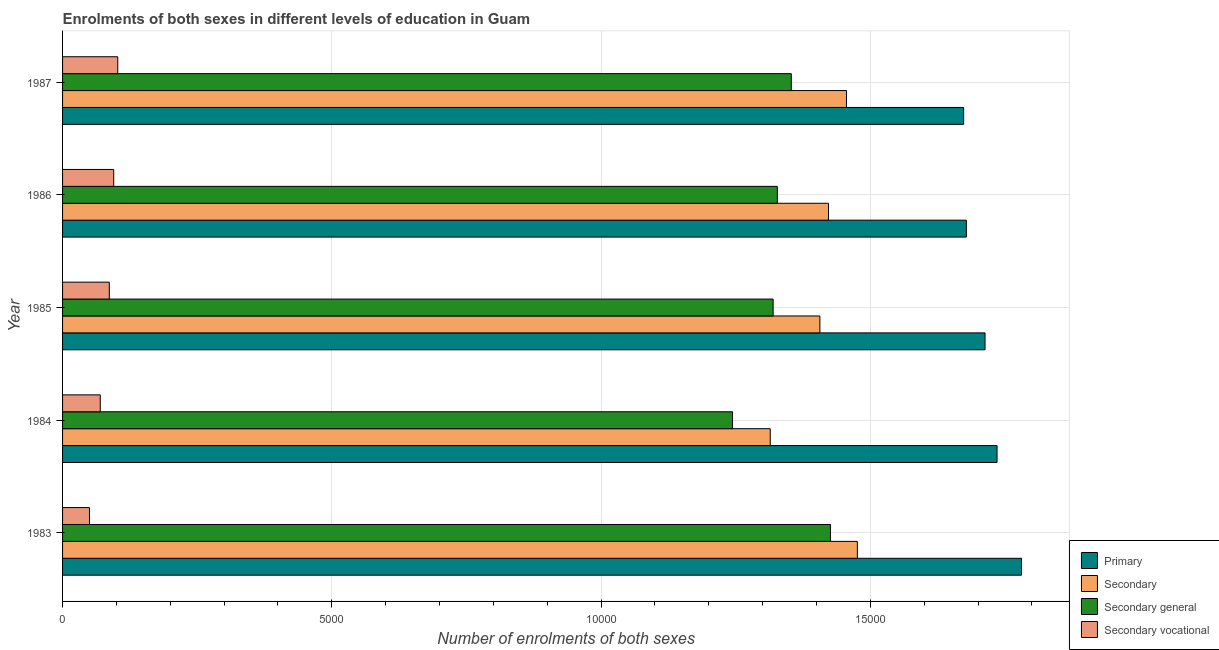How many different coloured bars are there?
Your answer should be very brief. 4. What is the label of the 4th group of bars from the top?
Your answer should be very brief. 1984. In how many cases, is the number of bars for a given year not equal to the number of legend labels?
Your answer should be compact. 0. What is the number of enrolments in secondary education in 1987?
Provide a succinct answer. 1.46e+04. Across all years, what is the maximum number of enrolments in primary education?
Keep it short and to the point. 1.78e+04. Across all years, what is the minimum number of enrolments in primary education?
Ensure brevity in your answer.  1.67e+04. What is the total number of enrolments in secondary general education in the graph?
Make the answer very short. 6.67e+04. What is the difference between the number of enrolments in secondary education in 1985 and that in 1987?
Provide a short and direct response. -494. What is the difference between the number of enrolments in primary education in 1985 and the number of enrolments in secondary general education in 1983?
Give a very brief answer. 2871. What is the average number of enrolments in secondary general education per year?
Make the answer very short. 1.33e+04. In the year 1985, what is the difference between the number of enrolments in secondary education and number of enrolments in secondary vocational education?
Your answer should be compact. 1.32e+04. What is the ratio of the number of enrolments in secondary education in 1985 to that in 1986?
Give a very brief answer. 0.99. What is the difference between the highest and the second highest number of enrolments in secondary general education?
Keep it short and to the point. 727. What is the difference between the highest and the lowest number of enrolments in primary education?
Offer a terse response. 1074. What does the 3rd bar from the top in 1986 represents?
Offer a very short reply. Secondary. What does the 4th bar from the bottom in 1987 represents?
Give a very brief answer. Secondary vocational. Are all the bars in the graph horizontal?
Give a very brief answer. Yes. What is the difference between two consecutive major ticks on the X-axis?
Provide a short and direct response. 5000. Are the values on the major ticks of X-axis written in scientific E-notation?
Offer a very short reply. No. Does the graph contain any zero values?
Give a very brief answer. No. Does the graph contain grids?
Your answer should be compact. Yes. Where does the legend appear in the graph?
Your answer should be very brief. Bottom right. What is the title of the graph?
Your response must be concise. Enrolments of both sexes in different levels of education in Guam. What is the label or title of the X-axis?
Your answer should be very brief. Number of enrolments of both sexes. What is the label or title of the Y-axis?
Ensure brevity in your answer.  Year. What is the Number of enrolments of both sexes of Primary in 1983?
Your answer should be very brief. 1.78e+04. What is the Number of enrolments of both sexes in Secondary in 1983?
Offer a very short reply. 1.48e+04. What is the Number of enrolments of both sexes of Secondary general in 1983?
Provide a succinct answer. 1.43e+04. What is the Number of enrolments of both sexes in Secondary vocational in 1983?
Make the answer very short. 500. What is the Number of enrolments of both sexes in Primary in 1984?
Your response must be concise. 1.74e+04. What is the Number of enrolments of both sexes in Secondary in 1984?
Offer a terse response. 1.31e+04. What is the Number of enrolments of both sexes in Secondary general in 1984?
Ensure brevity in your answer.  1.24e+04. What is the Number of enrolments of both sexes of Secondary vocational in 1984?
Provide a short and direct response. 700. What is the Number of enrolments of both sexes of Primary in 1985?
Provide a succinct answer. 1.71e+04. What is the Number of enrolments of both sexes in Secondary in 1985?
Offer a terse response. 1.41e+04. What is the Number of enrolments of both sexes of Secondary general in 1985?
Provide a short and direct response. 1.32e+04. What is the Number of enrolments of both sexes of Secondary vocational in 1985?
Ensure brevity in your answer.  868. What is the Number of enrolments of both sexes of Primary in 1986?
Offer a terse response. 1.68e+04. What is the Number of enrolments of both sexes of Secondary in 1986?
Give a very brief answer. 1.42e+04. What is the Number of enrolments of both sexes in Secondary general in 1986?
Provide a short and direct response. 1.33e+04. What is the Number of enrolments of both sexes in Secondary vocational in 1986?
Provide a succinct answer. 950. What is the Number of enrolments of both sexes in Primary in 1987?
Offer a very short reply. 1.67e+04. What is the Number of enrolments of both sexes in Secondary in 1987?
Your answer should be very brief. 1.46e+04. What is the Number of enrolments of both sexes of Secondary general in 1987?
Ensure brevity in your answer.  1.35e+04. What is the Number of enrolments of both sexes of Secondary vocational in 1987?
Keep it short and to the point. 1025. Across all years, what is the maximum Number of enrolments of both sexes in Primary?
Provide a short and direct response. 1.78e+04. Across all years, what is the maximum Number of enrolments of both sexes in Secondary?
Offer a terse response. 1.48e+04. Across all years, what is the maximum Number of enrolments of both sexes in Secondary general?
Make the answer very short. 1.43e+04. Across all years, what is the maximum Number of enrolments of both sexes of Secondary vocational?
Provide a short and direct response. 1025. Across all years, what is the minimum Number of enrolments of both sexes in Primary?
Provide a short and direct response. 1.67e+04. Across all years, what is the minimum Number of enrolments of both sexes in Secondary?
Make the answer very short. 1.31e+04. Across all years, what is the minimum Number of enrolments of both sexes of Secondary general?
Offer a terse response. 1.24e+04. Across all years, what is the minimum Number of enrolments of both sexes of Secondary vocational?
Make the answer very short. 500. What is the total Number of enrolments of both sexes of Primary in the graph?
Ensure brevity in your answer.  8.58e+04. What is the total Number of enrolments of both sexes in Secondary in the graph?
Your answer should be very brief. 7.07e+04. What is the total Number of enrolments of both sexes of Secondary general in the graph?
Ensure brevity in your answer.  6.67e+04. What is the total Number of enrolments of both sexes of Secondary vocational in the graph?
Offer a terse response. 4043. What is the difference between the Number of enrolments of both sexes in Primary in 1983 and that in 1984?
Provide a succinct answer. 454. What is the difference between the Number of enrolments of both sexes of Secondary in 1983 and that in 1984?
Provide a succinct answer. 1618. What is the difference between the Number of enrolments of both sexes of Secondary general in 1983 and that in 1984?
Provide a succinct answer. 1818. What is the difference between the Number of enrolments of both sexes in Secondary vocational in 1983 and that in 1984?
Your response must be concise. -200. What is the difference between the Number of enrolments of both sexes of Primary in 1983 and that in 1985?
Provide a short and direct response. 677. What is the difference between the Number of enrolments of both sexes of Secondary in 1983 and that in 1985?
Keep it short and to the point. 696. What is the difference between the Number of enrolments of both sexes of Secondary general in 1983 and that in 1985?
Give a very brief answer. 1064. What is the difference between the Number of enrolments of both sexes in Secondary vocational in 1983 and that in 1985?
Ensure brevity in your answer.  -368. What is the difference between the Number of enrolments of both sexes in Primary in 1983 and that in 1986?
Your response must be concise. 1024. What is the difference between the Number of enrolments of both sexes in Secondary in 1983 and that in 1986?
Provide a short and direct response. 536. What is the difference between the Number of enrolments of both sexes in Secondary general in 1983 and that in 1986?
Provide a succinct answer. 986. What is the difference between the Number of enrolments of both sexes in Secondary vocational in 1983 and that in 1986?
Offer a terse response. -450. What is the difference between the Number of enrolments of both sexes in Primary in 1983 and that in 1987?
Your answer should be compact. 1074. What is the difference between the Number of enrolments of both sexes in Secondary in 1983 and that in 1987?
Your response must be concise. 202. What is the difference between the Number of enrolments of both sexes of Secondary general in 1983 and that in 1987?
Keep it short and to the point. 727. What is the difference between the Number of enrolments of both sexes in Secondary vocational in 1983 and that in 1987?
Ensure brevity in your answer.  -525. What is the difference between the Number of enrolments of both sexes in Primary in 1984 and that in 1985?
Provide a short and direct response. 223. What is the difference between the Number of enrolments of both sexes of Secondary in 1984 and that in 1985?
Keep it short and to the point. -922. What is the difference between the Number of enrolments of both sexes of Secondary general in 1984 and that in 1985?
Provide a short and direct response. -754. What is the difference between the Number of enrolments of both sexes of Secondary vocational in 1984 and that in 1985?
Provide a short and direct response. -168. What is the difference between the Number of enrolments of both sexes of Primary in 1984 and that in 1986?
Offer a very short reply. 570. What is the difference between the Number of enrolments of both sexes of Secondary in 1984 and that in 1986?
Keep it short and to the point. -1082. What is the difference between the Number of enrolments of both sexes of Secondary general in 1984 and that in 1986?
Make the answer very short. -832. What is the difference between the Number of enrolments of both sexes of Secondary vocational in 1984 and that in 1986?
Make the answer very short. -250. What is the difference between the Number of enrolments of both sexes of Primary in 1984 and that in 1987?
Your answer should be compact. 620. What is the difference between the Number of enrolments of both sexes of Secondary in 1984 and that in 1987?
Keep it short and to the point. -1416. What is the difference between the Number of enrolments of both sexes of Secondary general in 1984 and that in 1987?
Offer a very short reply. -1091. What is the difference between the Number of enrolments of both sexes of Secondary vocational in 1984 and that in 1987?
Make the answer very short. -325. What is the difference between the Number of enrolments of both sexes of Primary in 1985 and that in 1986?
Keep it short and to the point. 347. What is the difference between the Number of enrolments of both sexes in Secondary in 1985 and that in 1986?
Ensure brevity in your answer.  -160. What is the difference between the Number of enrolments of both sexes of Secondary general in 1985 and that in 1986?
Make the answer very short. -78. What is the difference between the Number of enrolments of both sexes in Secondary vocational in 1985 and that in 1986?
Your answer should be very brief. -82. What is the difference between the Number of enrolments of both sexes in Primary in 1985 and that in 1987?
Ensure brevity in your answer.  397. What is the difference between the Number of enrolments of both sexes of Secondary in 1985 and that in 1987?
Your answer should be very brief. -494. What is the difference between the Number of enrolments of both sexes of Secondary general in 1985 and that in 1987?
Make the answer very short. -337. What is the difference between the Number of enrolments of both sexes of Secondary vocational in 1985 and that in 1987?
Your answer should be very brief. -157. What is the difference between the Number of enrolments of both sexes of Primary in 1986 and that in 1987?
Ensure brevity in your answer.  50. What is the difference between the Number of enrolments of both sexes of Secondary in 1986 and that in 1987?
Provide a short and direct response. -334. What is the difference between the Number of enrolments of both sexes of Secondary general in 1986 and that in 1987?
Offer a terse response. -259. What is the difference between the Number of enrolments of both sexes in Secondary vocational in 1986 and that in 1987?
Provide a succinct answer. -75. What is the difference between the Number of enrolments of both sexes in Primary in 1983 and the Number of enrolments of both sexes in Secondary in 1984?
Ensure brevity in your answer.  4666. What is the difference between the Number of enrolments of both sexes in Primary in 1983 and the Number of enrolments of both sexes in Secondary general in 1984?
Offer a very short reply. 5366. What is the difference between the Number of enrolments of both sexes of Primary in 1983 and the Number of enrolments of both sexes of Secondary vocational in 1984?
Keep it short and to the point. 1.71e+04. What is the difference between the Number of enrolments of both sexes in Secondary in 1983 and the Number of enrolments of both sexes in Secondary general in 1984?
Provide a short and direct response. 2318. What is the difference between the Number of enrolments of both sexes in Secondary in 1983 and the Number of enrolments of both sexes in Secondary vocational in 1984?
Your answer should be compact. 1.41e+04. What is the difference between the Number of enrolments of both sexes of Secondary general in 1983 and the Number of enrolments of both sexes of Secondary vocational in 1984?
Your answer should be very brief. 1.36e+04. What is the difference between the Number of enrolments of both sexes in Primary in 1983 and the Number of enrolments of both sexes in Secondary in 1985?
Offer a very short reply. 3744. What is the difference between the Number of enrolments of both sexes in Primary in 1983 and the Number of enrolments of both sexes in Secondary general in 1985?
Your answer should be compact. 4612. What is the difference between the Number of enrolments of both sexes in Primary in 1983 and the Number of enrolments of both sexes in Secondary vocational in 1985?
Your answer should be compact. 1.69e+04. What is the difference between the Number of enrolments of both sexes of Secondary in 1983 and the Number of enrolments of both sexes of Secondary general in 1985?
Provide a succinct answer. 1564. What is the difference between the Number of enrolments of both sexes in Secondary in 1983 and the Number of enrolments of both sexes in Secondary vocational in 1985?
Your answer should be compact. 1.39e+04. What is the difference between the Number of enrolments of both sexes of Secondary general in 1983 and the Number of enrolments of both sexes of Secondary vocational in 1985?
Offer a terse response. 1.34e+04. What is the difference between the Number of enrolments of both sexes of Primary in 1983 and the Number of enrolments of both sexes of Secondary in 1986?
Your answer should be compact. 3584. What is the difference between the Number of enrolments of both sexes in Primary in 1983 and the Number of enrolments of both sexes in Secondary general in 1986?
Provide a succinct answer. 4534. What is the difference between the Number of enrolments of both sexes of Primary in 1983 and the Number of enrolments of both sexes of Secondary vocational in 1986?
Offer a very short reply. 1.69e+04. What is the difference between the Number of enrolments of both sexes of Secondary in 1983 and the Number of enrolments of both sexes of Secondary general in 1986?
Give a very brief answer. 1486. What is the difference between the Number of enrolments of both sexes in Secondary in 1983 and the Number of enrolments of both sexes in Secondary vocational in 1986?
Keep it short and to the point. 1.38e+04. What is the difference between the Number of enrolments of both sexes of Secondary general in 1983 and the Number of enrolments of both sexes of Secondary vocational in 1986?
Ensure brevity in your answer.  1.33e+04. What is the difference between the Number of enrolments of both sexes of Primary in 1983 and the Number of enrolments of both sexes of Secondary in 1987?
Keep it short and to the point. 3250. What is the difference between the Number of enrolments of both sexes in Primary in 1983 and the Number of enrolments of both sexes in Secondary general in 1987?
Offer a terse response. 4275. What is the difference between the Number of enrolments of both sexes of Primary in 1983 and the Number of enrolments of both sexes of Secondary vocational in 1987?
Provide a short and direct response. 1.68e+04. What is the difference between the Number of enrolments of both sexes in Secondary in 1983 and the Number of enrolments of both sexes in Secondary general in 1987?
Ensure brevity in your answer.  1227. What is the difference between the Number of enrolments of both sexes of Secondary in 1983 and the Number of enrolments of both sexes of Secondary vocational in 1987?
Offer a terse response. 1.37e+04. What is the difference between the Number of enrolments of both sexes in Secondary general in 1983 and the Number of enrolments of both sexes in Secondary vocational in 1987?
Provide a short and direct response. 1.32e+04. What is the difference between the Number of enrolments of both sexes in Primary in 1984 and the Number of enrolments of both sexes in Secondary in 1985?
Your answer should be compact. 3290. What is the difference between the Number of enrolments of both sexes of Primary in 1984 and the Number of enrolments of both sexes of Secondary general in 1985?
Offer a very short reply. 4158. What is the difference between the Number of enrolments of both sexes in Primary in 1984 and the Number of enrolments of both sexes in Secondary vocational in 1985?
Make the answer very short. 1.65e+04. What is the difference between the Number of enrolments of both sexes in Secondary in 1984 and the Number of enrolments of both sexes in Secondary general in 1985?
Keep it short and to the point. -54. What is the difference between the Number of enrolments of both sexes in Secondary in 1984 and the Number of enrolments of both sexes in Secondary vocational in 1985?
Make the answer very short. 1.23e+04. What is the difference between the Number of enrolments of both sexes in Secondary general in 1984 and the Number of enrolments of both sexes in Secondary vocational in 1985?
Offer a terse response. 1.16e+04. What is the difference between the Number of enrolments of both sexes of Primary in 1984 and the Number of enrolments of both sexes of Secondary in 1986?
Ensure brevity in your answer.  3130. What is the difference between the Number of enrolments of both sexes in Primary in 1984 and the Number of enrolments of both sexes in Secondary general in 1986?
Your answer should be very brief. 4080. What is the difference between the Number of enrolments of both sexes in Primary in 1984 and the Number of enrolments of both sexes in Secondary vocational in 1986?
Your answer should be compact. 1.64e+04. What is the difference between the Number of enrolments of both sexes in Secondary in 1984 and the Number of enrolments of both sexes in Secondary general in 1986?
Your response must be concise. -132. What is the difference between the Number of enrolments of both sexes of Secondary in 1984 and the Number of enrolments of both sexes of Secondary vocational in 1986?
Provide a short and direct response. 1.22e+04. What is the difference between the Number of enrolments of both sexes in Secondary general in 1984 and the Number of enrolments of both sexes in Secondary vocational in 1986?
Make the answer very short. 1.15e+04. What is the difference between the Number of enrolments of both sexes of Primary in 1984 and the Number of enrolments of both sexes of Secondary in 1987?
Ensure brevity in your answer.  2796. What is the difference between the Number of enrolments of both sexes of Primary in 1984 and the Number of enrolments of both sexes of Secondary general in 1987?
Offer a very short reply. 3821. What is the difference between the Number of enrolments of both sexes of Primary in 1984 and the Number of enrolments of both sexes of Secondary vocational in 1987?
Give a very brief answer. 1.63e+04. What is the difference between the Number of enrolments of both sexes in Secondary in 1984 and the Number of enrolments of both sexes in Secondary general in 1987?
Provide a succinct answer. -391. What is the difference between the Number of enrolments of both sexes of Secondary in 1984 and the Number of enrolments of both sexes of Secondary vocational in 1987?
Ensure brevity in your answer.  1.21e+04. What is the difference between the Number of enrolments of both sexes of Secondary general in 1984 and the Number of enrolments of both sexes of Secondary vocational in 1987?
Provide a succinct answer. 1.14e+04. What is the difference between the Number of enrolments of both sexes in Primary in 1985 and the Number of enrolments of both sexes in Secondary in 1986?
Offer a terse response. 2907. What is the difference between the Number of enrolments of both sexes of Primary in 1985 and the Number of enrolments of both sexes of Secondary general in 1986?
Provide a short and direct response. 3857. What is the difference between the Number of enrolments of both sexes of Primary in 1985 and the Number of enrolments of both sexes of Secondary vocational in 1986?
Offer a terse response. 1.62e+04. What is the difference between the Number of enrolments of both sexes in Secondary in 1985 and the Number of enrolments of both sexes in Secondary general in 1986?
Your response must be concise. 790. What is the difference between the Number of enrolments of both sexes in Secondary in 1985 and the Number of enrolments of both sexes in Secondary vocational in 1986?
Make the answer very short. 1.31e+04. What is the difference between the Number of enrolments of both sexes in Secondary general in 1985 and the Number of enrolments of both sexes in Secondary vocational in 1986?
Make the answer very short. 1.22e+04. What is the difference between the Number of enrolments of both sexes of Primary in 1985 and the Number of enrolments of both sexes of Secondary in 1987?
Offer a terse response. 2573. What is the difference between the Number of enrolments of both sexes in Primary in 1985 and the Number of enrolments of both sexes in Secondary general in 1987?
Offer a very short reply. 3598. What is the difference between the Number of enrolments of both sexes in Primary in 1985 and the Number of enrolments of both sexes in Secondary vocational in 1987?
Give a very brief answer. 1.61e+04. What is the difference between the Number of enrolments of both sexes of Secondary in 1985 and the Number of enrolments of both sexes of Secondary general in 1987?
Your response must be concise. 531. What is the difference between the Number of enrolments of both sexes in Secondary in 1985 and the Number of enrolments of both sexes in Secondary vocational in 1987?
Provide a short and direct response. 1.30e+04. What is the difference between the Number of enrolments of both sexes in Secondary general in 1985 and the Number of enrolments of both sexes in Secondary vocational in 1987?
Your answer should be compact. 1.22e+04. What is the difference between the Number of enrolments of both sexes of Primary in 1986 and the Number of enrolments of both sexes of Secondary in 1987?
Ensure brevity in your answer.  2226. What is the difference between the Number of enrolments of both sexes of Primary in 1986 and the Number of enrolments of both sexes of Secondary general in 1987?
Ensure brevity in your answer.  3251. What is the difference between the Number of enrolments of both sexes in Primary in 1986 and the Number of enrolments of both sexes in Secondary vocational in 1987?
Your answer should be very brief. 1.58e+04. What is the difference between the Number of enrolments of both sexes of Secondary in 1986 and the Number of enrolments of both sexes of Secondary general in 1987?
Offer a terse response. 691. What is the difference between the Number of enrolments of both sexes in Secondary in 1986 and the Number of enrolments of both sexes in Secondary vocational in 1987?
Give a very brief answer. 1.32e+04. What is the difference between the Number of enrolments of both sexes in Secondary general in 1986 and the Number of enrolments of both sexes in Secondary vocational in 1987?
Your answer should be very brief. 1.22e+04. What is the average Number of enrolments of both sexes of Primary per year?
Give a very brief answer. 1.72e+04. What is the average Number of enrolments of both sexes in Secondary per year?
Give a very brief answer. 1.41e+04. What is the average Number of enrolments of both sexes in Secondary general per year?
Your answer should be compact. 1.33e+04. What is the average Number of enrolments of both sexes in Secondary vocational per year?
Your answer should be very brief. 808.6. In the year 1983, what is the difference between the Number of enrolments of both sexes of Primary and Number of enrolments of both sexes of Secondary?
Your answer should be very brief. 3048. In the year 1983, what is the difference between the Number of enrolments of both sexes in Primary and Number of enrolments of both sexes in Secondary general?
Provide a short and direct response. 3548. In the year 1983, what is the difference between the Number of enrolments of both sexes of Primary and Number of enrolments of both sexes of Secondary vocational?
Keep it short and to the point. 1.73e+04. In the year 1983, what is the difference between the Number of enrolments of both sexes of Secondary and Number of enrolments of both sexes of Secondary general?
Your response must be concise. 500. In the year 1983, what is the difference between the Number of enrolments of both sexes in Secondary and Number of enrolments of both sexes in Secondary vocational?
Give a very brief answer. 1.43e+04. In the year 1983, what is the difference between the Number of enrolments of both sexes of Secondary general and Number of enrolments of both sexes of Secondary vocational?
Offer a very short reply. 1.38e+04. In the year 1984, what is the difference between the Number of enrolments of both sexes of Primary and Number of enrolments of both sexes of Secondary?
Keep it short and to the point. 4212. In the year 1984, what is the difference between the Number of enrolments of both sexes of Primary and Number of enrolments of both sexes of Secondary general?
Keep it short and to the point. 4912. In the year 1984, what is the difference between the Number of enrolments of both sexes in Primary and Number of enrolments of both sexes in Secondary vocational?
Give a very brief answer. 1.67e+04. In the year 1984, what is the difference between the Number of enrolments of both sexes of Secondary and Number of enrolments of both sexes of Secondary general?
Offer a very short reply. 700. In the year 1984, what is the difference between the Number of enrolments of both sexes of Secondary and Number of enrolments of both sexes of Secondary vocational?
Provide a succinct answer. 1.24e+04. In the year 1984, what is the difference between the Number of enrolments of both sexes of Secondary general and Number of enrolments of both sexes of Secondary vocational?
Provide a short and direct response. 1.17e+04. In the year 1985, what is the difference between the Number of enrolments of both sexes of Primary and Number of enrolments of both sexes of Secondary?
Offer a very short reply. 3067. In the year 1985, what is the difference between the Number of enrolments of both sexes of Primary and Number of enrolments of both sexes of Secondary general?
Provide a short and direct response. 3935. In the year 1985, what is the difference between the Number of enrolments of both sexes in Primary and Number of enrolments of both sexes in Secondary vocational?
Give a very brief answer. 1.63e+04. In the year 1985, what is the difference between the Number of enrolments of both sexes in Secondary and Number of enrolments of both sexes in Secondary general?
Your answer should be compact. 868. In the year 1985, what is the difference between the Number of enrolments of both sexes of Secondary and Number of enrolments of both sexes of Secondary vocational?
Give a very brief answer. 1.32e+04. In the year 1985, what is the difference between the Number of enrolments of both sexes in Secondary general and Number of enrolments of both sexes in Secondary vocational?
Provide a succinct answer. 1.23e+04. In the year 1986, what is the difference between the Number of enrolments of both sexes in Primary and Number of enrolments of both sexes in Secondary?
Ensure brevity in your answer.  2560. In the year 1986, what is the difference between the Number of enrolments of both sexes of Primary and Number of enrolments of both sexes of Secondary general?
Offer a terse response. 3510. In the year 1986, what is the difference between the Number of enrolments of both sexes in Primary and Number of enrolments of both sexes in Secondary vocational?
Provide a short and direct response. 1.58e+04. In the year 1986, what is the difference between the Number of enrolments of both sexes of Secondary and Number of enrolments of both sexes of Secondary general?
Offer a terse response. 950. In the year 1986, what is the difference between the Number of enrolments of both sexes of Secondary and Number of enrolments of both sexes of Secondary vocational?
Your response must be concise. 1.33e+04. In the year 1986, what is the difference between the Number of enrolments of both sexes in Secondary general and Number of enrolments of both sexes in Secondary vocational?
Keep it short and to the point. 1.23e+04. In the year 1987, what is the difference between the Number of enrolments of both sexes of Primary and Number of enrolments of both sexes of Secondary?
Ensure brevity in your answer.  2176. In the year 1987, what is the difference between the Number of enrolments of both sexes in Primary and Number of enrolments of both sexes in Secondary general?
Give a very brief answer. 3201. In the year 1987, what is the difference between the Number of enrolments of both sexes of Primary and Number of enrolments of both sexes of Secondary vocational?
Your response must be concise. 1.57e+04. In the year 1987, what is the difference between the Number of enrolments of both sexes of Secondary and Number of enrolments of both sexes of Secondary general?
Your answer should be very brief. 1025. In the year 1987, what is the difference between the Number of enrolments of both sexes of Secondary and Number of enrolments of both sexes of Secondary vocational?
Give a very brief answer. 1.35e+04. In the year 1987, what is the difference between the Number of enrolments of both sexes in Secondary general and Number of enrolments of both sexes in Secondary vocational?
Make the answer very short. 1.25e+04. What is the ratio of the Number of enrolments of both sexes of Primary in 1983 to that in 1984?
Keep it short and to the point. 1.03. What is the ratio of the Number of enrolments of both sexes in Secondary in 1983 to that in 1984?
Provide a short and direct response. 1.12. What is the ratio of the Number of enrolments of both sexes in Secondary general in 1983 to that in 1984?
Your answer should be very brief. 1.15. What is the ratio of the Number of enrolments of both sexes of Secondary vocational in 1983 to that in 1984?
Your answer should be very brief. 0.71. What is the ratio of the Number of enrolments of both sexes of Primary in 1983 to that in 1985?
Give a very brief answer. 1.04. What is the ratio of the Number of enrolments of both sexes in Secondary in 1983 to that in 1985?
Your response must be concise. 1.05. What is the ratio of the Number of enrolments of both sexes in Secondary general in 1983 to that in 1985?
Your answer should be very brief. 1.08. What is the ratio of the Number of enrolments of both sexes in Secondary vocational in 1983 to that in 1985?
Ensure brevity in your answer.  0.58. What is the ratio of the Number of enrolments of both sexes in Primary in 1983 to that in 1986?
Make the answer very short. 1.06. What is the ratio of the Number of enrolments of both sexes of Secondary in 1983 to that in 1986?
Ensure brevity in your answer.  1.04. What is the ratio of the Number of enrolments of both sexes in Secondary general in 1983 to that in 1986?
Ensure brevity in your answer.  1.07. What is the ratio of the Number of enrolments of both sexes of Secondary vocational in 1983 to that in 1986?
Your response must be concise. 0.53. What is the ratio of the Number of enrolments of both sexes in Primary in 1983 to that in 1987?
Provide a short and direct response. 1.06. What is the ratio of the Number of enrolments of both sexes in Secondary in 1983 to that in 1987?
Give a very brief answer. 1.01. What is the ratio of the Number of enrolments of both sexes in Secondary general in 1983 to that in 1987?
Provide a succinct answer. 1.05. What is the ratio of the Number of enrolments of both sexes of Secondary vocational in 1983 to that in 1987?
Offer a terse response. 0.49. What is the ratio of the Number of enrolments of both sexes in Secondary in 1984 to that in 1985?
Your response must be concise. 0.93. What is the ratio of the Number of enrolments of both sexes in Secondary general in 1984 to that in 1985?
Offer a very short reply. 0.94. What is the ratio of the Number of enrolments of both sexes of Secondary vocational in 1984 to that in 1985?
Keep it short and to the point. 0.81. What is the ratio of the Number of enrolments of both sexes in Primary in 1984 to that in 1986?
Provide a short and direct response. 1.03. What is the ratio of the Number of enrolments of both sexes in Secondary in 1984 to that in 1986?
Your response must be concise. 0.92. What is the ratio of the Number of enrolments of both sexes in Secondary general in 1984 to that in 1986?
Keep it short and to the point. 0.94. What is the ratio of the Number of enrolments of both sexes of Secondary vocational in 1984 to that in 1986?
Make the answer very short. 0.74. What is the ratio of the Number of enrolments of both sexes of Primary in 1984 to that in 1987?
Provide a succinct answer. 1.04. What is the ratio of the Number of enrolments of both sexes of Secondary in 1984 to that in 1987?
Your answer should be very brief. 0.9. What is the ratio of the Number of enrolments of both sexes of Secondary general in 1984 to that in 1987?
Make the answer very short. 0.92. What is the ratio of the Number of enrolments of both sexes of Secondary vocational in 1984 to that in 1987?
Your response must be concise. 0.68. What is the ratio of the Number of enrolments of both sexes of Primary in 1985 to that in 1986?
Your response must be concise. 1.02. What is the ratio of the Number of enrolments of both sexes of Secondary in 1985 to that in 1986?
Your answer should be compact. 0.99. What is the ratio of the Number of enrolments of both sexes of Secondary general in 1985 to that in 1986?
Your answer should be very brief. 0.99. What is the ratio of the Number of enrolments of both sexes in Secondary vocational in 1985 to that in 1986?
Your answer should be compact. 0.91. What is the ratio of the Number of enrolments of both sexes in Primary in 1985 to that in 1987?
Your answer should be very brief. 1.02. What is the ratio of the Number of enrolments of both sexes of Secondary in 1985 to that in 1987?
Your answer should be very brief. 0.97. What is the ratio of the Number of enrolments of both sexes of Secondary general in 1985 to that in 1987?
Offer a very short reply. 0.98. What is the ratio of the Number of enrolments of both sexes in Secondary vocational in 1985 to that in 1987?
Ensure brevity in your answer.  0.85. What is the ratio of the Number of enrolments of both sexes of Primary in 1986 to that in 1987?
Give a very brief answer. 1. What is the ratio of the Number of enrolments of both sexes of Secondary in 1986 to that in 1987?
Make the answer very short. 0.98. What is the ratio of the Number of enrolments of both sexes of Secondary general in 1986 to that in 1987?
Ensure brevity in your answer.  0.98. What is the ratio of the Number of enrolments of both sexes of Secondary vocational in 1986 to that in 1987?
Keep it short and to the point. 0.93. What is the difference between the highest and the second highest Number of enrolments of both sexes in Primary?
Make the answer very short. 454. What is the difference between the highest and the second highest Number of enrolments of both sexes of Secondary?
Your response must be concise. 202. What is the difference between the highest and the second highest Number of enrolments of both sexes of Secondary general?
Offer a terse response. 727. What is the difference between the highest and the lowest Number of enrolments of both sexes in Primary?
Provide a short and direct response. 1074. What is the difference between the highest and the lowest Number of enrolments of both sexes in Secondary?
Your answer should be compact. 1618. What is the difference between the highest and the lowest Number of enrolments of both sexes in Secondary general?
Keep it short and to the point. 1818. What is the difference between the highest and the lowest Number of enrolments of both sexes in Secondary vocational?
Keep it short and to the point. 525. 